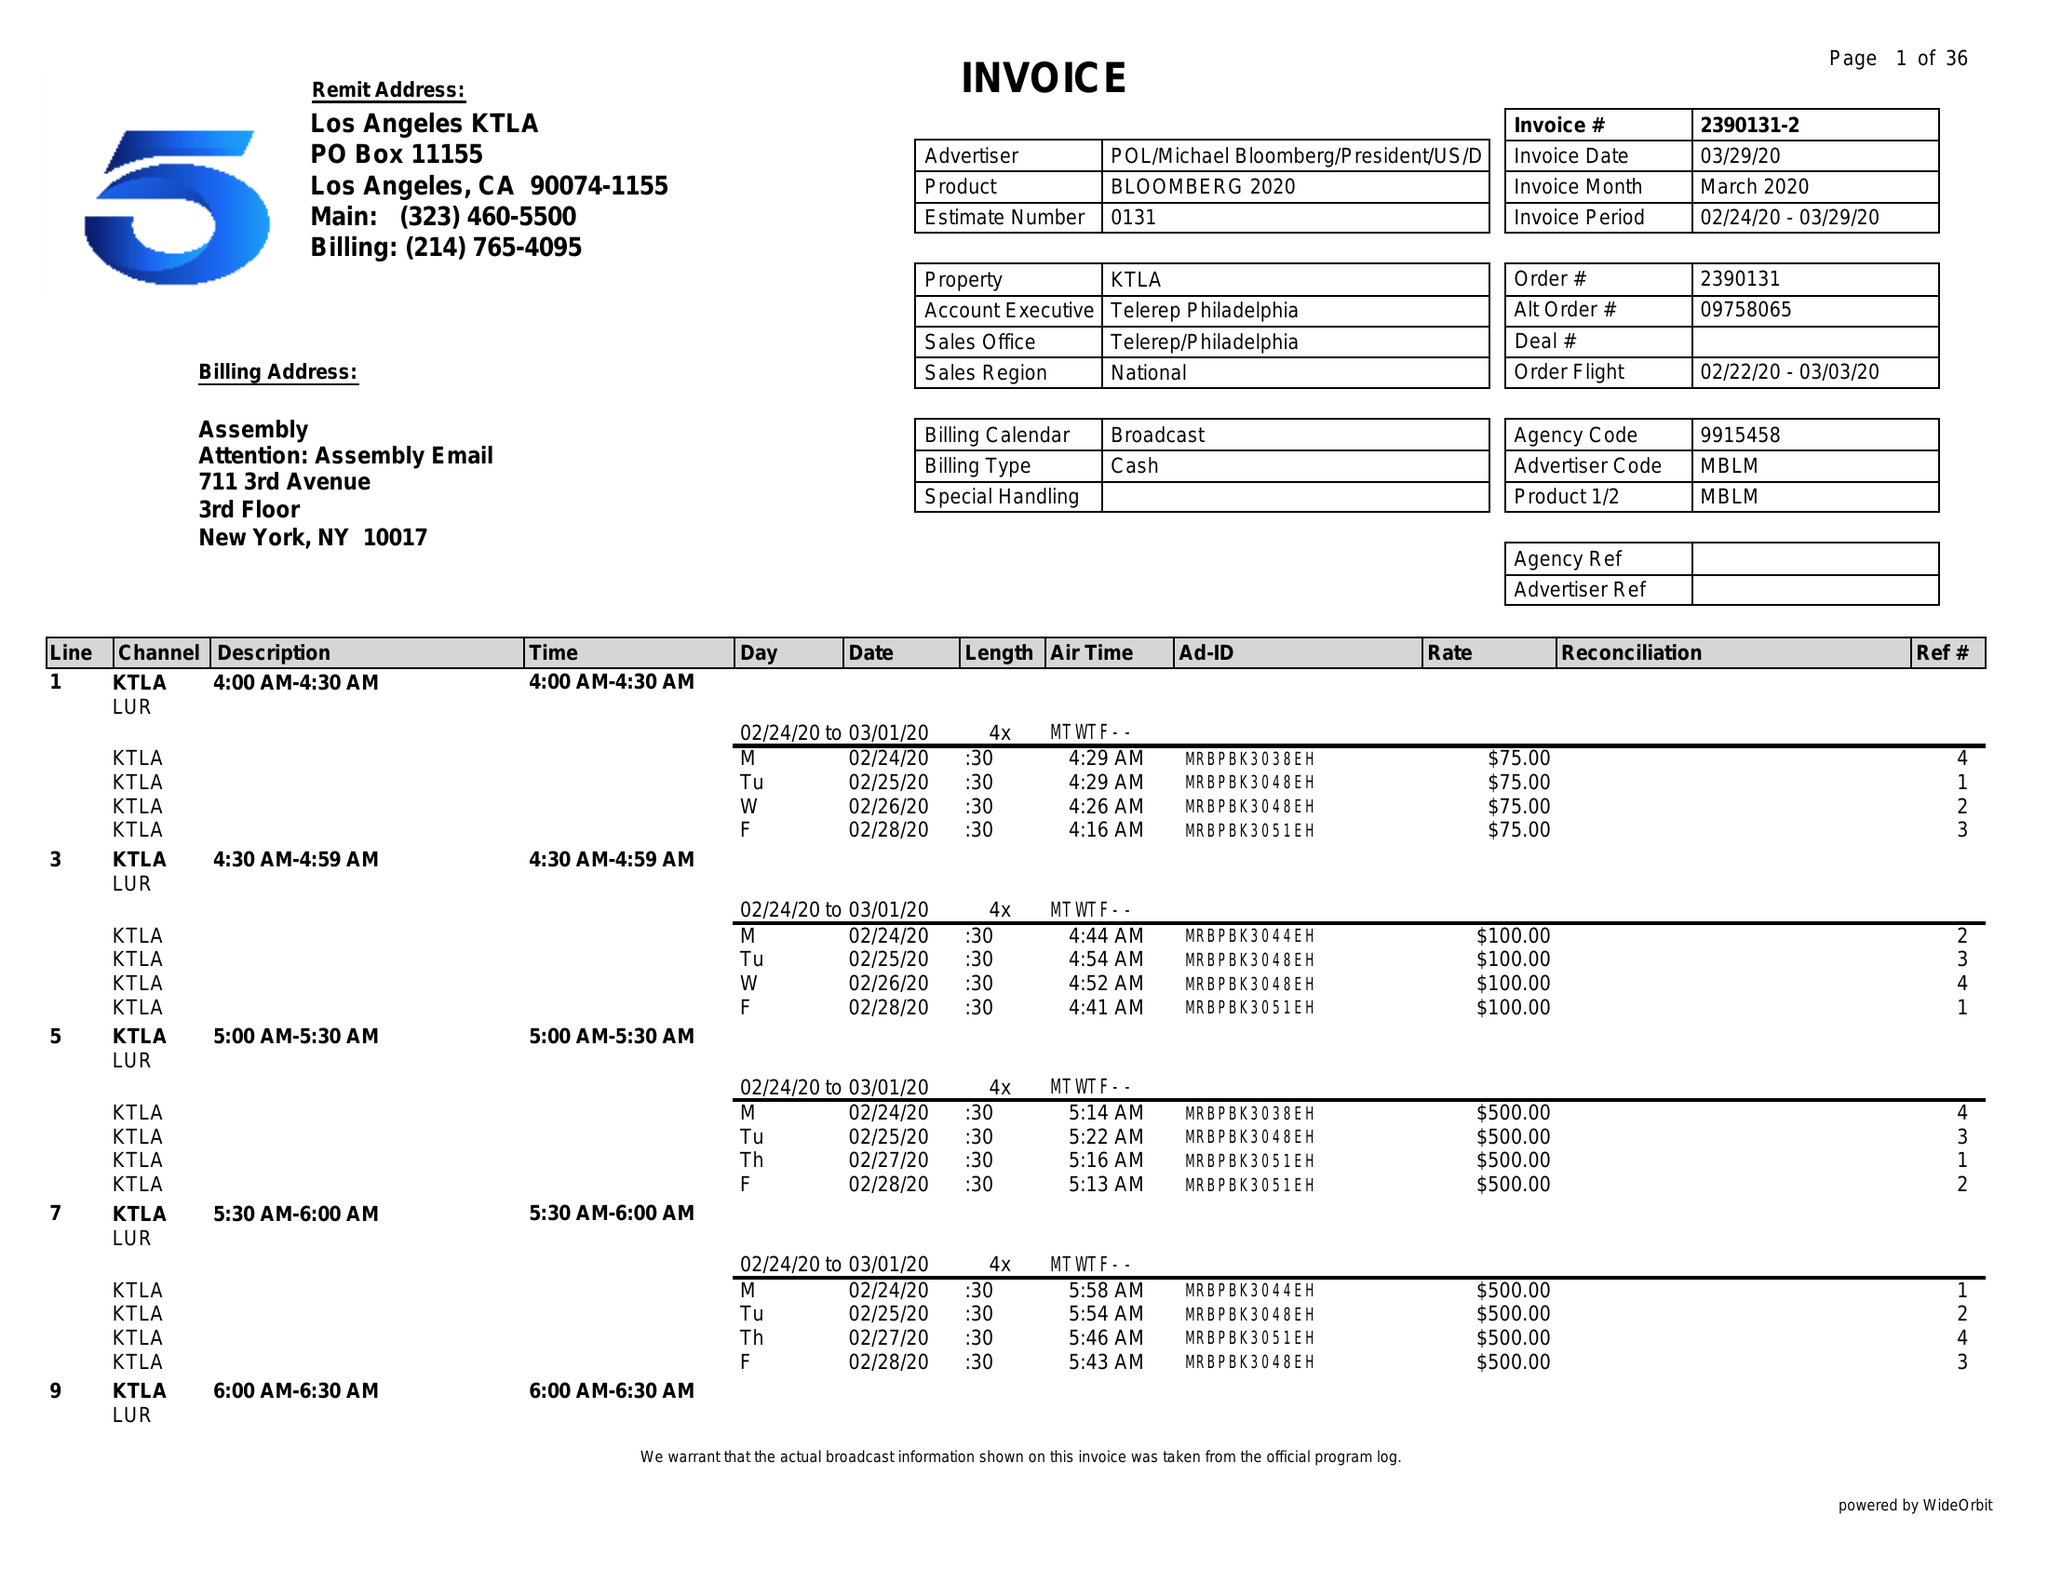What is the value for the advertiser?
Answer the question using a single word or phrase. POL/MICHAELBLOOMBERG/PRESIDENT/US/DEM 